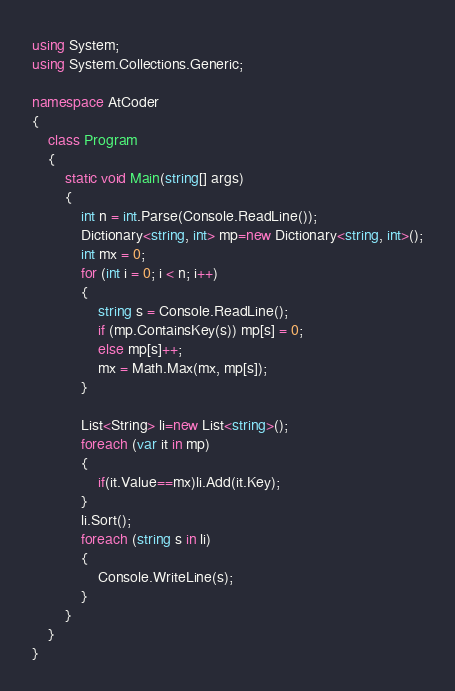Convert code to text. <code><loc_0><loc_0><loc_500><loc_500><_C#_>using System;
using System.Collections.Generic;

namespace AtCoder
{
    class Program
    {
        static void Main(string[] args)
        {
            int n = int.Parse(Console.ReadLine());
            Dictionary<string, int> mp=new Dictionary<string, int>();
            int mx = 0;
            for (int i = 0; i < n; i++)
            {
                string s = Console.ReadLine();
                if (mp.ContainsKey(s)) mp[s] = 0;
                else mp[s]++;
                mx = Math.Max(mx, mp[s]);
            }

            List<String> li=new List<string>();
            foreach (var it in mp)
            {
                if(it.Value==mx)li.Add(it.Key);
            }
            li.Sort();
            foreach (string s in li)
            {
                Console.WriteLine(s);
            }
        }
    }
}</code> 